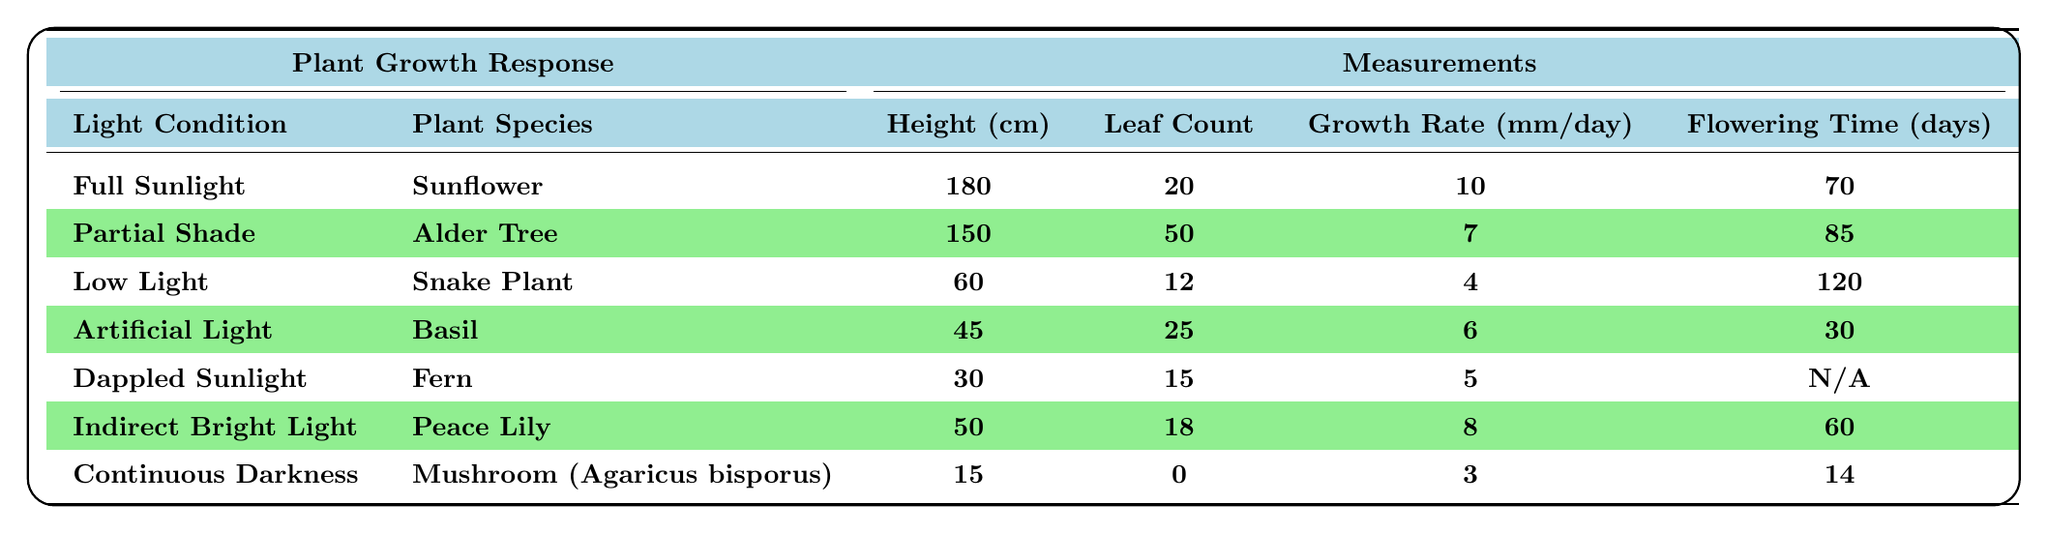What is the average height of plants grown in full sunlight? The height of the plant grown in full sunlight (Sunflower) is 180 cm. Since there is only one plant species listed under this condition, the average height is also 180 cm.
Answer: 180 cm Which plant species has the highest leaf count? The Alder Tree has the highest leaf count at 50 leaves. By comparing the leaf counts of all the plant species listed, Alder Tree (50) has more leaves than any others.
Answer: Alder Tree What is the growth rate of the Snake Plant? The growth rate of the Snake Plant is listed as 4 mm per day in the table, which directly provides this information.
Answer: 4 mm per day How many days does it take for Basil to flower? The flowering time for Basil is reported in the table as 30 days, which is a direct retrieval from the data.
Answer: 30 days Which light condition resulted in the lowest average height among the listed plants? The plant with the lowest average height is the Mushroom (Agaricus bisporus), which has a height of 15 cm. Upon examining all the conditions, this height is the least.
Answer: Continuous Darkness If you combine the growth rates of plants in full sunlight and partial shade, what is the total growth rate? In full sunlight, the growth rate is 10 mm/day (Sunflower), and in partial shade, it is 7 mm/day (Alder Tree). Adding these values gives 10 + 7 = 17 mm/day.
Answer: 17 mm/day Is it true that the Fern takes longer to flower than the Snake Plant? The Fern has a flowering time of "N/A," while the Snake Plant takes 120 days to flower. Since "N/A" cannot be compared quantitatively, we cannot confirm this statement as true.
Answer: No What is the average number of leaves for plants grown in indirect bright light and artificial light combined? The Peace Lily in indirect bright light has 18 leaves, and Basil in artificial light has 25 leaves. The sum of leaves is 18 + 25 = 43, and dividing by the number of plants (2 species) gives an average of 43/2 = 21.5 leaves.
Answer: 21.5 leaves How much taller is the Alder Tree compared to the Snake Plant? The Alder Tree has an average height of 150 cm, while the Snake Plant has an average height of 60 cm. The difference in height is 150 - 60 = 90 cm, meaning the Alder Tree is 90 cm taller.
Answer: 90 cm Which type of lighting results in the fastest growth rate? The fastest growth rate is in full sunlight with 10 mm per day, as observed by comparing the growth rates across different light conditions.
Answer: Full Sunlight If we consider plants with a leaf count above 15, how many species are there? The plants with a leaf count above 15 are the Alder Tree (50) and Basil (25), making it a total of two species with more than 15 leaves.
Answer: 2 species 